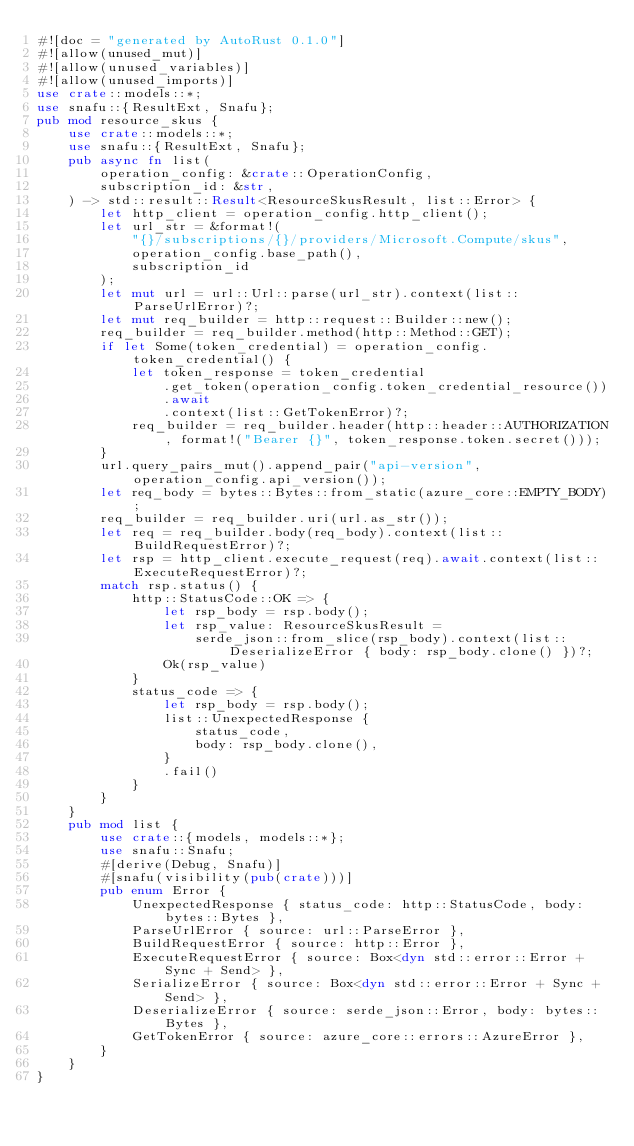Convert code to text. <code><loc_0><loc_0><loc_500><loc_500><_Rust_>#![doc = "generated by AutoRust 0.1.0"]
#![allow(unused_mut)]
#![allow(unused_variables)]
#![allow(unused_imports)]
use crate::models::*;
use snafu::{ResultExt, Snafu};
pub mod resource_skus {
    use crate::models::*;
    use snafu::{ResultExt, Snafu};
    pub async fn list(
        operation_config: &crate::OperationConfig,
        subscription_id: &str,
    ) -> std::result::Result<ResourceSkusResult, list::Error> {
        let http_client = operation_config.http_client();
        let url_str = &format!(
            "{}/subscriptions/{}/providers/Microsoft.Compute/skus",
            operation_config.base_path(),
            subscription_id
        );
        let mut url = url::Url::parse(url_str).context(list::ParseUrlError)?;
        let mut req_builder = http::request::Builder::new();
        req_builder = req_builder.method(http::Method::GET);
        if let Some(token_credential) = operation_config.token_credential() {
            let token_response = token_credential
                .get_token(operation_config.token_credential_resource())
                .await
                .context(list::GetTokenError)?;
            req_builder = req_builder.header(http::header::AUTHORIZATION, format!("Bearer {}", token_response.token.secret()));
        }
        url.query_pairs_mut().append_pair("api-version", operation_config.api_version());
        let req_body = bytes::Bytes::from_static(azure_core::EMPTY_BODY);
        req_builder = req_builder.uri(url.as_str());
        let req = req_builder.body(req_body).context(list::BuildRequestError)?;
        let rsp = http_client.execute_request(req).await.context(list::ExecuteRequestError)?;
        match rsp.status() {
            http::StatusCode::OK => {
                let rsp_body = rsp.body();
                let rsp_value: ResourceSkusResult =
                    serde_json::from_slice(rsp_body).context(list::DeserializeError { body: rsp_body.clone() })?;
                Ok(rsp_value)
            }
            status_code => {
                let rsp_body = rsp.body();
                list::UnexpectedResponse {
                    status_code,
                    body: rsp_body.clone(),
                }
                .fail()
            }
        }
    }
    pub mod list {
        use crate::{models, models::*};
        use snafu::Snafu;
        #[derive(Debug, Snafu)]
        #[snafu(visibility(pub(crate)))]
        pub enum Error {
            UnexpectedResponse { status_code: http::StatusCode, body: bytes::Bytes },
            ParseUrlError { source: url::ParseError },
            BuildRequestError { source: http::Error },
            ExecuteRequestError { source: Box<dyn std::error::Error + Sync + Send> },
            SerializeError { source: Box<dyn std::error::Error + Sync + Send> },
            DeserializeError { source: serde_json::Error, body: bytes::Bytes },
            GetTokenError { source: azure_core::errors::AzureError },
        }
    }
}
</code> 